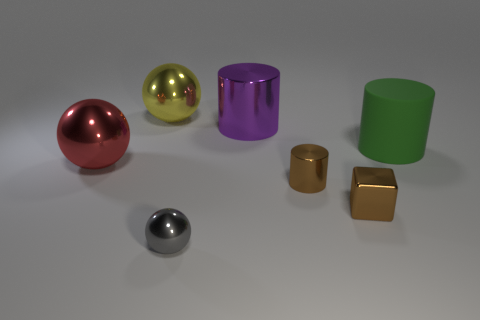Are there any other things that are the same color as the small cube?
Make the answer very short. Yes. Do the sphere on the right side of the yellow sphere and the large cylinder that is on the left side of the big green matte cylinder have the same material?
Your answer should be compact. Yes. What is the material of the cylinder that is on the left side of the small metallic block and behind the large red thing?
Offer a very short reply. Metal. There is a large red metal object; does it have the same shape as the large purple shiny thing that is left of the big rubber thing?
Make the answer very short. No. What is the big cylinder that is left of the cylinder that is on the right side of the brown object that is behind the tiny metal block made of?
Offer a terse response. Metal. How many other objects are there of the same size as the yellow ball?
Offer a terse response. 3. Does the tiny shiny block have the same color as the big rubber cylinder?
Give a very brief answer. No. There is a big object left of the ball that is behind the big red metal thing; what number of big green rubber cylinders are in front of it?
Your response must be concise. 0. What material is the tiny brown thing in front of the brown cylinder in front of the big yellow shiny sphere?
Provide a succinct answer. Metal. Are there any tiny brown rubber things that have the same shape as the purple shiny thing?
Your answer should be compact. No. 